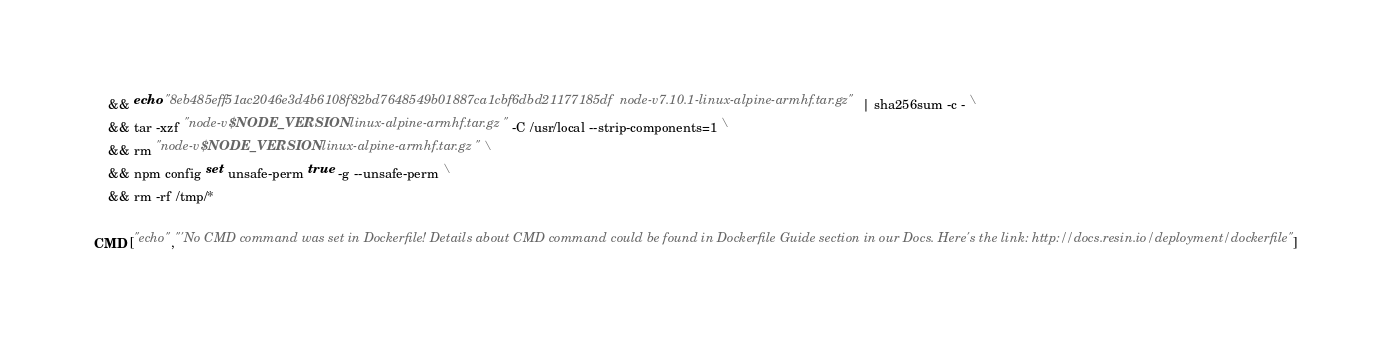<code> <loc_0><loc_0><loc_500><loc_500><_Dockerfile_>	&& echo "8eb485eff51ac2046e3d4b6108f82bd7648549b01887ca1cbf6dbd21177185df  node-v7.10.1-linux-alpine-armhf.tar.gz" | sha256sum -c - \
	&& tar -xzf "node-v$NODE_VERSION-linux-alpine-armhf.tar.gz" -C /usr/local --strip-components=1 \
	&& rm "node-v$NODE_VERSION-linux-alpine-armhf.tar.gz" \
	&& npm config set unsafe-perm true -g --unsafe-perm \
	&& rm -rf /tmp/*

CMD ["echo","'No CMD command was set in Dockerfile! Details about CMD command could be found in Dockerfile Guide section in our Docs. Here's the link: http://docs.resin.io/deployment/dockerfile"]
</code> 